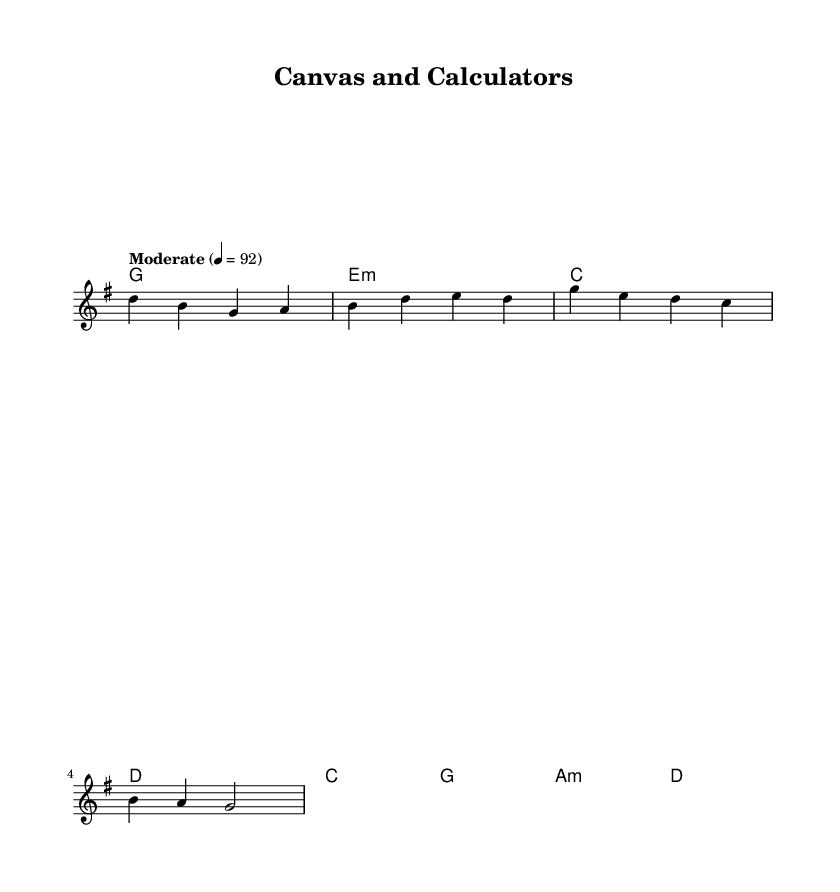What is the key signature of this music? The key signature is G major, which has one sharp (F#). This can be determined by looking at the key indicated at the beginning of the staff.
Answer: G major What is the time signature? The time signature is 4/4, which means there are four beats in each measure and the quarter note gets one beat. This is indicated at the start of the score.
Answer: 4/4 What is the tempo marking? The tempo marking is "Moderate," with a metronome marking of 92 beats per minute. This can be found in the tempo indication at the beginning of the score.
Answer: Moderate How many measures are in the verse section? The verse section consists of 4 measures, which can be counted by looking at the melody and harmonies above.
Answer: 4 What type of chord is used in the first measure? The chord used in the first measure is G major. This can be identified by the chord names indicated above the staff in the first measure.
Answer: G What is the main contrast depicted in the lyrics of this song? The main contrast depicted in the lyrics is between artistic expression and analytical reasoning, as mentioned in the phrases about colors and numbers. This reflects the central theme of the song.
Answer: Artistic and analytical Which section contains the lyrics "We're two sides of the same coin"? This lyric appears in the chorus section of the song, which can be identified by its placement after the verse in the song structure.
Answer: Chorus 